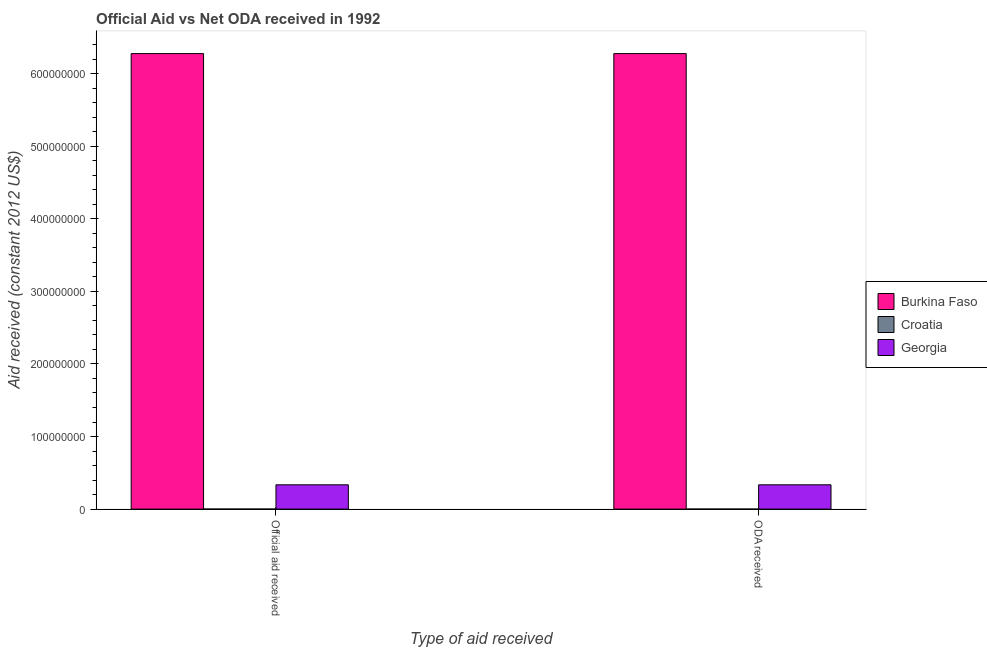How many different coloured bars are there?
Offer a terse response. 3. How many bars are there on the 2nd tick from the left?
Offer a terse response. 3. What is the label of the 1st group of bars from the left?
Provide a succinct answer. Official aid received. What is the official aid received in Croatia?
Your answer should be very brief. 2.00e+04. Across all countries, what is the maximum oda received?
Your answer should be very brief. 6.28e+08. Across all countries, what is the minimum official aid received?
Ensure brevity in your answer.  2.00e+04. In which country was the official aid received maximum?
Your answer should be very brief. Burkina Faso. In which country was the oda received minimum?
Give a very brief answer. Croatia. What is the total official aid received in the graph?
Make the answer very short. 6.61e+08. What is the difference between the oda received in Burkina Faso and that in Georgia?
Offer a very short reply. 5.94e+08. What is the difference between the official aid received in Croatia and the oda received in Burkina Faso?
Provide a short and direct response. -6.28e+08. What is the average oda received per country?
Offer a very short reply. 2.20e+08. What is the difference between the oda received and official aid received in Burkina Faso?
Offer a very short reply. 0. What is the ratio of the official aid received in Croatia to that in Burkina Faso?
Your answer should be compact. 3.1861847031272405e-5. What does the 2nd bar from the left in ODA received represents?
Keep it short and to the point. Croatia. What does the 2nd bar from the right in ODA received represents?
Give a very brief answer. Croatia. How many bars are there?
Your answer should be very brief. 6. What is the difference between two consecutive major ticks on the Y-axis?
Ensure brevity in your answer.  1.00e+08. Are the values on the major ticks of Y-axis written in scientific E-notation?
Keep it short and to the point. No. Does the graph contain any zero values?
Give a very brief answer. No. Where does the legend appear in the graph?
Your response must be concise. Center right. How are the legend labels stacked?
Offer a very short reply. Vertical. What is the title of the graph?
Provide a short and direct response. Official Aid vs Net ODA received in 1992 . Does "Madagascar" appear as one of the legend labels in the graph?
Provide a short and direct response. No. What is the label or title of the X-axis?
Your response must be concise. Type of aid received. What is the label or title of the Y-axis?
Your answer should be very brief. Aid received (constant 2012 US$). What is the Aid received (constant 2012 US$) in Burkina Faso in Official aid received?
Your answer should be very brief. 6.28e+08. What is the Aid received (constant 2012 US$) in Croatia in Official aid received?
Ensure brevity in your answer.  2.00e+04. What is the Aid received (constant 2012 US$) in Georgia in Official aid received?
Your answer should be very brief. 3.35e+07. What is the Aid received (constant 2012 US$) in Burkina Faso in ODA received?
Your answer should be very brief. 6.28e+08. What is the Aid received (constant 2012 US$) in Georgia in ODA received?
Ensure brevity in your answer.  3.35e+07. Across all Type of aid received, what is the maximum Aid received (constant 2012 US$) of Burkina Faso?
Your response must be concise. 6.28e+08. Across all Type of aid received, what is the maximum Aid received (constant 2012 US$) of Georgia?
Ensure brevity in your answer.  3.35e+07. Across all Type of aid received, what is the minimum Aid received (constant 2012 US$) in Burkina Faso?
Provide a succinct answer. 6.28e+08. Across all Type of aid received, what is the minimum Aid received (constant 2012 US$) in Croatia?
Ensure brevity in your answer.  2.00e+04. Across all Type of aid received, what is the minimum Aid received (constant 2012 US$) of Georgia?
Give a very brief answer. 3.35e+07. What is the total Aid received (constant 2012 US$) in Burkina Faso in the graph?
Your answer should be compact. 1.26e+09. What is the total Aid received (constant 2012 US$) in Georgia in the graph?
Your answer should be very brief. 6.70e+07. What is the difference between the Aid received (constant 2012 US$) of Burkina Faso in Official aid received and the Aid received (constant 2012 US$) of Croatia in ODA received?
Keep it short and to the point. 6.28e+08. What is the difference between the Aid received (constant 2012 US$) in Burkina Faso in Official aid received and the Aid received (constant 2012 US$) in Georgia in ODA received?
Your answer should be compact. 5.94e+08. What is the difference between the Aid received (constant 2012 US$) in Croatia in Official aid received and the Aid received (constant 2012 US$) in Georgia in ODA received?
Your answer should be very brief. -3.35e+07. What is the average Aid received (constant 2012 US$) of Burkina Faso per Type of aid received?
Your answer should be very brief. 6.28e+08. What is the average Aid received (constant 2012 US$) of Croatia per Type of aid received?
Make the answer very short. 2.00e+04. What is the average Aid received (constant 2012 US$) of Georgia per Type of aid received?
Provide a succinct answer. 3.35e+07. What is the difference between the Aid received (constant 2012 US$) of Burkina Faso and Aid received (constant 2012 US$) of Croatia in Official aid received?
Offer a terse response. 6.28e+08. What is the difference between the Aid received (constant 2012 US$) in Burkina Faso and Aid received (constant 2012 US$) in Georgia in Official aid received?
Keep it short and to the point. 5.94e+08. What is the difference between the Aid received (constant 2012 US$) of Croatia and Aid received (constant 2012 US$) of Georgia in Official aid received?
Keep it short and to the point. -3.35e+07. What is the difference between the Aid received (constant 2012 US$) of Burkina Faso and Aid received (constant 2012 US$) of Croatia in ODA received?
Offer a terse response. 6.28e+08. What is the difference between the Aid received (constant 2012 US$) in Burkina Faso and Aid received (constant 2012 US$) in Georgia in ODA received?
Offer a very short reply. 5.94e+08. What is the difference between the Aid received (constant 2012 US$) of Croatia and Aid received (constant 2012 US$) of Georgia in ODA received?
Your answer should be compact. -3.35e+07. What is the ratio of the Aid received (constant 2012 US$) in Burkina Faso in Official aid received to that in ODA received?
Your answer should be very brief. 1. What is the ratio of the Aid received (constant 2012 US$) of Croatia in Official aid received to that in ODA received?
Provide a short and direct response. 1. What is the ratio of the Aid received (constant 2012 US$) in Georgia in Official aid received to that in ODA received?
Offer a terse response. 1. What is the difference between the highest and the second highest Aid received (constant 2012 US$) in Burkina Faso?
Ensure brevity in your answer.  0. What is the difference between the highest and the second highest Aid received (constant 2012 US$) of Croatia?
Offer a terse response. 0. What is the difference between the highest and the lowest Aid received (constant 2012 US$) in Croatia?
Provide a succinct answer. 0. What is the difference between the highest and the lowest Aid received (constant 2012 US$) of Georgia?
Your answer should be compact. 0. 